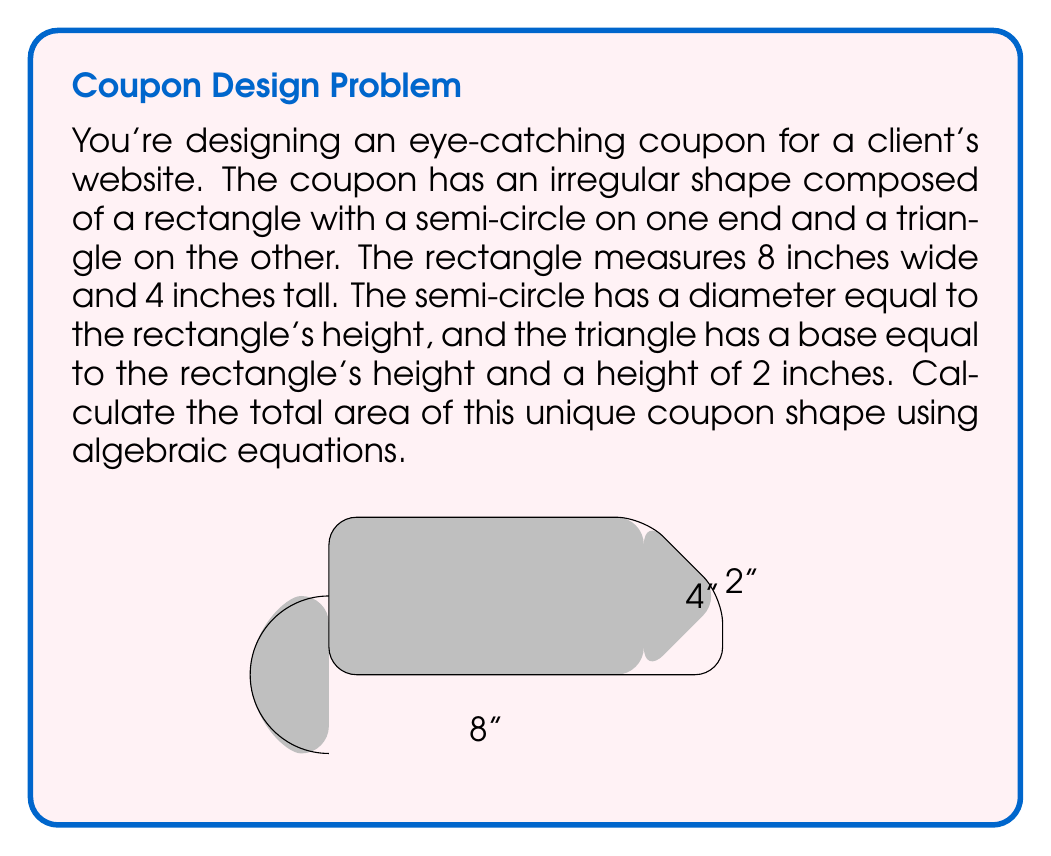Help me with this question. Let's break this down step-by-step:

1) The total area will be the sum of the areas of the rectangle, semi-circle, and triangle.

2) Area of the rectangle:
   $A_r = l \times w = 8 \times 4 = 32$ sq inches

3) Area of the semi-circle:
   The radius is half the height of the rectangle: $r = 4/2 = 2$ inches
   Area of a full circle: $A_c = \pi r^2$
   Area of semi-circle: $A_s = \frac{1}{2} \pi r^2 = \frac{1}{2} \pi (2)^2 = 2\pi$ sq inches

4) Area of the triangle:
   Base $b = 4$ inches, height $h = 2$ inches
   $A_t = \frac{1}{2} b h = \frac{1}{2} \times 4 \times 2 = 4$ sq inches

5) Total area:
   $A_{total} = A_r + A_s + A_t$
   $A_{total} = 32 + 2\pi + 4$
   $A_{total} = 36 + 2\pi$ sq inches

Therefore, the total area of the coupon is $36 + 2\pi$ square inches.
Answer: $36 + 2\pi$ sq inches 